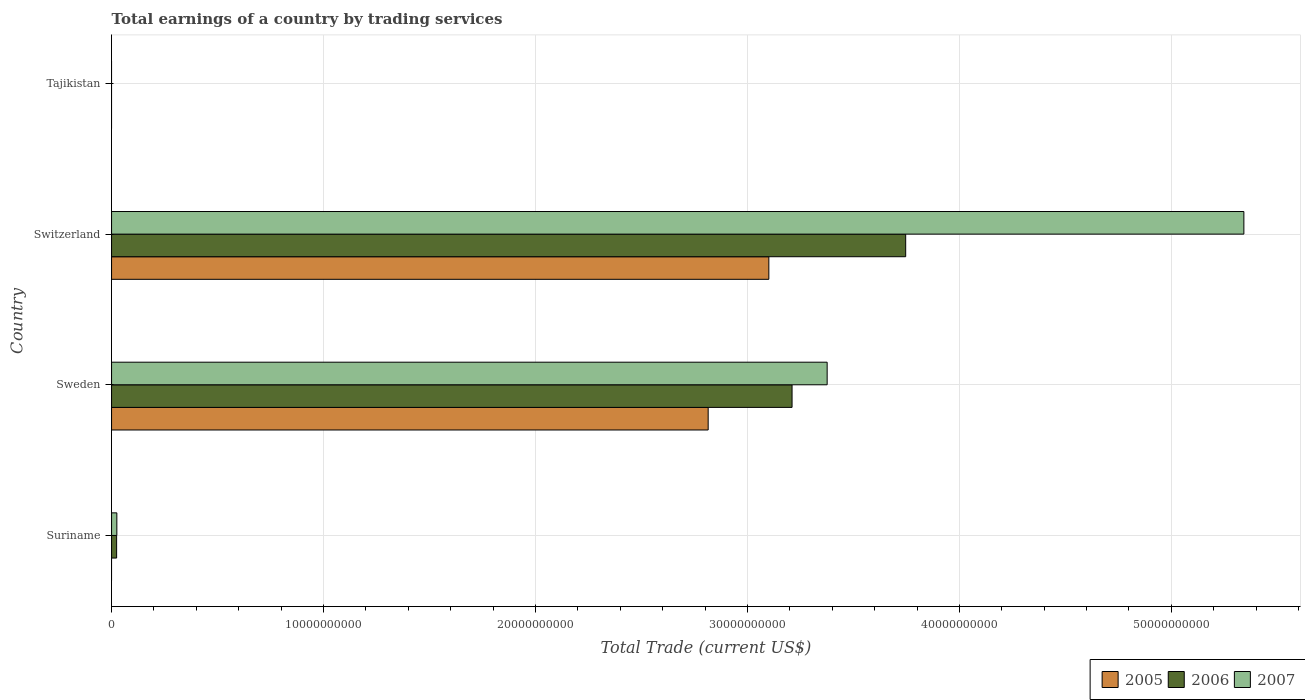Are the number of bars per tick equal to the number of legend labels?
Ensure brevity in your answer.  No. Are the number of bars on each tick of the Y-axis equal?
Keep it short and to the point. No. How many bars are there on the 1st tick from the top?
Provide a short and direct response. 0. How many bars are there on the 3rd tick from the bottom?
Provide a succinct answer. 3. What is the label of the 2nd group of bars from the top?
Provide a short and direct response. Switzerland. In how many cases, is the number of bars for a given country not equal to the number of legend labels?
Provide a succinct answer. 2. What is the total earnings in 2005 in Suriname?
Give a very brief answer. 0. Across all countries, what is the maximum total earnings in 2006?
Keep it short and to the point. 3.75e+1. In which country was the total earnings in 2006 maximum?
Make the answer very short. Switzerland. What is the total total earnings in 2005 in the graph?
Provide a succinct answer. 5.92e+1. What is the difference between the total earnings in 2007 in Suriname and that in Switzerland?
Provide a short and direct response. -5.32e+1. What is the difference between the total earnings in 2006 in Suriname and the total earnings in 2005 in Switzerland?
Offer a terse response. -3.08e+1. What is the average total earnings in 2005 per country?
Provide a short and direct response. 1.48e+1. What is the difference between the total earnings in 2005 and total earnings in 2007 in Switzerland?
Your response must be concise. -2.24e+1. What is the ratio of the total earnings in 2007 in Suriname to that in Sweden?
Provide a succinct answer. 0.01. Is the total earnings in 2007 in Suriname less than that in Sweden?
Provide a succinct answer. Yes. What is the difference between the highest and the second highest total earnings in 2006?
Your answer should be compact. 5.36e+09. What is the difference between the highest and the lowest total earnings in 2005?
Your answer should be compact. 3.10e+1. How many bars are there?
Your answer should be compact. 8. How many countries are there in the graph?
Your answer should be very brief. 4. What is the difference between two consecutive major ticks on the X-axis?
Provide a short and direct response. 1.00e+1. Are the values on the major ticks of X-axis written in scientific E-notation?
Give a very brief answer. No. Does the graph contain any zero values?
Provide a succinct answer. Yes. Does the graph contain grids?
Provide a short and direct response. Yes. How are the legend labels stacked?
Offer a terse response. Horizontal. What is the title of the graph?
Offer a terse response. Total earnings of a country by trading services. What is the label or title of the X-axis?
Provide a short and direct response. Total Trade (current US$). What is the Total Trade (current US$) in 2005 in Suriname?
Keep it short and to the point. 0. What is the Total Trade (current US$) in 2006 in Suriname?
Your answer should be very brief. 2.39e+08. What is the Total Trade (current US$) of 2007 in Suriname?
Provide a succinct answer. 2.50e+08. What is the Total Trade (current US$) in 2005 in Sweden?
Make the answer very short. 2.81e+1. What is the Total Trade (current US$) of 2006 in Sweden?
Offer a terse response. 3.21e+1. What is the Total Trade (current US$) of 2007 in Sweden?
Your answer should be compact. 3.38e+1. What is the Total Trade (current US$) of 2005 in Switzerland?
Provide a short and direct response. 3.10e+1. What is the Total Trade (current US$) in 2006 in Switzerland?
Offer a very short reply. 3.75e+1. What is the Total Trade (current US$) in 2007 in Switzerland?
Your answer should be very brief. 5.34e+1. What is the Total Trade (current US$) of 2005 in Tajikistan?
Provide a succinct answer. 0. What is the Total Trade (current US$) of 2006 in Tajikistan?
Provide a short and direct response. 0. What is the Total Trade (current US$) of 2007 in Tajikistan?
Give a very brief answer. 0. Across all countries, what is the maximum Total Trade (current US$) of 2005?
Make the answer very short. 3.10e+1. Across all countries, what is the maximum Total Trade (current US$) of 2006?
Ensure brevity in your answer.  3.75e+1. Across all countries, what is the maximum Total Trade (current US$) of 2007?
Ensure brevity in your answer.  5.34e+1. Across all countries, what is the minimum Total Trade (current US$) of 2005?
Give a very brief answer. 0. Across all countries, what is the minimum Total Trade (current US$) in 2006?
Your answer should be very brief. 0. What is the total Total Trade (current US$) of 2005 in the graph?
Offer a very short reply. 5.92e+1. What is the total Total Trade (current US$) of 2006 in the graph?
Make the answer very short. 6.98e+1. What is the total Total Trade (current US$) in 2007 in the graph?
Provide a succinct answer. 8.74e+1. What is the difference between the Total Trade (current US$) of 2006 in Suriname and that in Sweden?
Your response must be concise. -3.19e+1. What is the difference between the Total Trade (current US$) in 2007 in Suriname and that in Sweden?
Keep it short and to the point. -3.35e+1. What is the difference between the Total Trade (current US$) in 2006 in Suriname and that in Switzerland?
Keep it short and to the point. -3.72e+1. What is the difference between the Total Trade (current US$) of 2007 in Suriname and that in Switzerland?
Your answer should be compact. -5.32e+1. What is the difference between the Total Trade (current US$) of 2005 in Sweden and that in Switzerland?
Offer a terse response. -2.86e+09. What is the difference between the Total Trade (current US$) in 2006 in Sweden and that in Switzerland?
Offer a very short reply. -5.36e+09. What is the difference between the Total Trade (current US$) of 2007 in Sweden and that in Switzerland?
Offer a terse response. -1.97e+1. What is the difference between the Total Trade (current US$) of 2006 in Suriname and the Total Trade (current US$) of 2007 in Sweden?
Your answer should be compact. -3.35e+1. What is the difference between the Total Trade (current US$) in 2006 in Suriname and the Total Trade (current US$) in 2007 in Switzerland?
Your answer should be compact. -5.32e+1. What is the difference between the Total Trade (current US$) of 2005 in Sweden and the Total Trade (current US$) of 2006 in Switzerland?
Your answer should be compact. -9.32e+09. What is the difference between the Total Trade (current US$) of 2005 in Sweden and the Total Trade (current US$) of 2007 in Switzerland?
Offer a very short reply. -2.53e+1. What is the difference between the Total Trade (current US$) of 2006 in Sweden and the Total Trade (current US$) of 2007 in Switzerland?
Make the answer very short. -2.13e+1. What is the average Total Trade (current US$) in 2005 per country?
Your answer should be very brief. 1.48e+1. What is the average Total Trade (current US$) of 2006 per country?
Provide a short and direct response. 1.75e+1. What is the average Total Trade (current US$) of 2007 per country?
Offer a terse response. 2.19e+1. What is the difference between the Total Trade (current US$) of 2006 and Total Trade (current US$) of 2007 in Suriname?
Provide a short and direct response. -1.05e+07. What is the difference between the Total Trade (current US$) of 2005 and Total Trade (current US$) of 2006 in Sweden?
Offer a very short reply. -3.96e+09. What is the difference between the Total Trade (current US$) in 2005 and Total Trade (current US$) in 2007 in Sweden?
Keep it short and to the point. -5.61e+09. What is the difference between the Total Trade (current US$) of 2006 and Total Trade (current US$) of 2007 in Sweden?
Your answer should be very brief. -1.66e+09. What is the difference between the Total Trade (current US$) of 2005 and Total Trade (current US$) of 2006 in Switzerland?
Offer a terse response. -6.46e+09. What is the difference between the Total Trade (current US$) of 2005 and Total Trade (current US$) of 2007 in Switzerland?
Make the answer very short. -2.24e+1. What is the difference between the Total Trade (current US$) of 2006 and Total Trade (current US$) of 2007 in Switzerland?
Your response must be concise. -1.60e+1. What is the ratio of the Total Trade (current US$) of 2006 in Suriname to that in Sweden?
Give a very brief answer. 0.01. What is the ratio of the Total Trade (current US$) of 2007 in Suriname to that in Sweden?
Keep it short and to the point. 0.01. What is the ratio of the Total Trade (current US$) of 2006 in Suriname to that in Switzerland?
Ensure brevity in your answer.  0.01. What is the ratio of the Total Trade (current US$) of 2007 in Suriname to that in Switzerland?
Ensure brevity in your answer.  0. What is the ratio of the Total Trade (current US$) in 2005 in Sweden to that in Switzerland?
Offer a terse response. 0.91. What is the ratio of the Total Trade (current US$) in 2006 in Sweden to that in Switzerland?
Ensure brevity in your answer.  0.86. What is the ratio of the Total Trade (current US$) in 2007 in Sweden to that in Switzerland?
Offer a very short reply. 0.63. What is the difference between the highest and the second highest Total Trade (current US$) in 2006?
Your answer should be very brief. 5.36e+09. What is the difference between the highest and the second highest Total Trade (current US$) of 2007?
Make the answer very short. 1.97e+1. What is the difference between the highest and the lowest Total Trade (current US$) of 2005?
Your answer should be compact. 3.10e+1. What is the difference between the highest and the lowest Total Trade (current US$) of 2006?
Ensure brevity in your answer.  3.75e+1. What is the difference between the highest and the lowest Total Trade (current US$) of 2007?
Offer a terse response. 5.34e+1. 